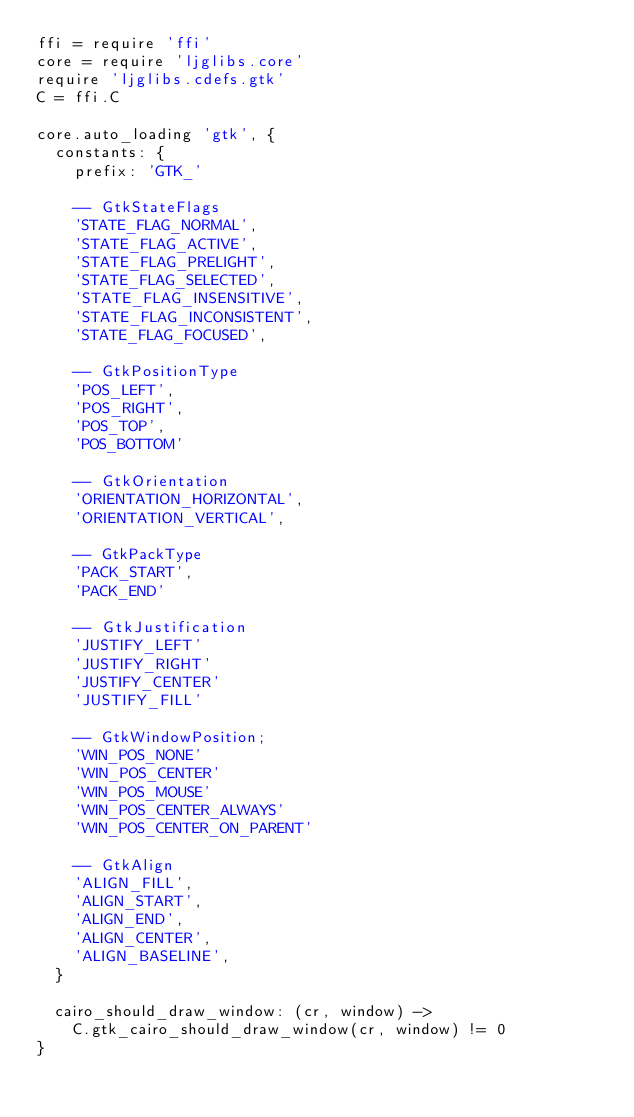<code> <loc_0><loc_0><loc_500><loc_500><_MoonScript_>ffi = require 'ffi'
core = require 'ljglibs.core'
require 'ljglibs.cdefs.gtk'
C = ffi.C

core.auto_loading 'gtk', {
  constants: {
    prefix: 'GTK_'

    -- GtkStateFlags
    'STATE_FLAG_NORMAL',
    'STATE_FLAG_ACTIVE',
    'STATE_FLAG_PRELIGHT',
    'STATE_FLAG_SELECTED',
    'STATE_FLAG_INSENSITIVE',
    'STATE_FLAG_INCONSISTENT',
    'STATE_FLAG_FOCUSED',

    -- GtkPositionType
    'POS_LEFT',
    'POS_RIGHT',
    'POS_TOP',
    'POS_BOTTOM'

    -- GtkOrientation
    'ORIENTATION_HORIZONTAL',
    'ORIENTATION_VERTICAL',

    -- GtkPackType
    'PACK_START',
    'PACK_END'

    -- GtkJustification
    'JUSTIFY_LEFT'
    'JUSTIFY_RIGHT'
    'JUSTIFY_CENTER'
    'JUSTIFY_FILL'

    -- GtkWindowPosition;
    'WIN_POS_NONE'
    'WIN_POS_CENTER'
    'WIN_POS_MOUSE'
    'WIN_POS_CENTER_ALWAYS'
    'WIN_POS_CENTER_ON_PARENT'

    -- GtkAlign
    'ALIGN_FILL',
    'ALIGN_START',
    'ALIGN_END',
    'ALIGN_CENTER',
    'ALIGN_BASELINE',
  }

  cairo_should_draw_window: (cr, window) ->
    C.gtk_cairo_should_draw_window(cr, window) != 0
}
</code> 